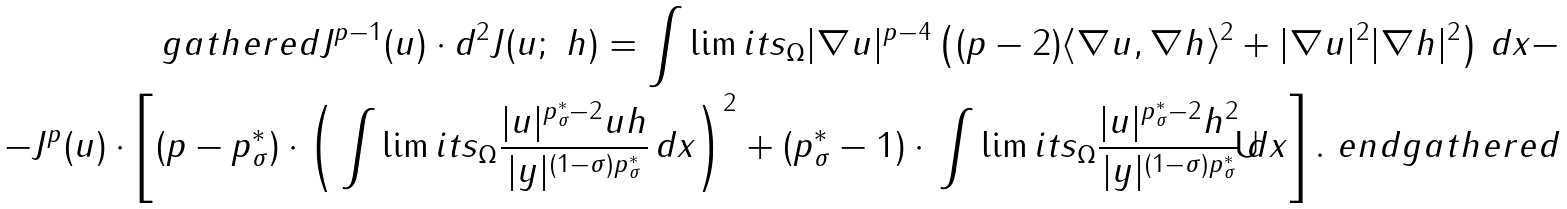<formula> <loc_0><loc_0><loc_500><loc_500>\ g a t h e r e d J ^ { p - 1 } ( u ) \cdot d ^ { 2 } J ( u ; \ h ) = \int \lim i t s _ { \Omega } | \nabla u | ^ { p - 4 } \left ( ( p - 2 ) \langle \nabla u , \nabla h \rangle ^ { 2 } + | \nabla u | ^ { 2 } | \nabla h | ^ { 2 } \right ) \, d x - \\ - J ^ { p } ( u ) \cdot \left [ ( p - p ^ { * } _ { \sigma } ) \cdot \left ( \, \int \lim i t s _ { \Omega } \frac { | u | ^ { p ^ { * } _ { \sigma } - 2 } u h } { | y | ^ { ( 1 - \sigma ) p ^ { * } _ { \sigma } } } \, d x \right ) ^ { 2 } + ( p ^ { * } _ { \sigma } - 1 ) \cdot \, \int \lim i t s _ { \Omega } \frac { | u | ^ { p ^ { * } _ { \sigma } - 2 } h ^ { 2 } } { | y | ^ { ( 1 - \sigma ) p ^ { * } _ { \sigma } } } \, d x \right ] . \ e n d g a t h e r e d</formula> 